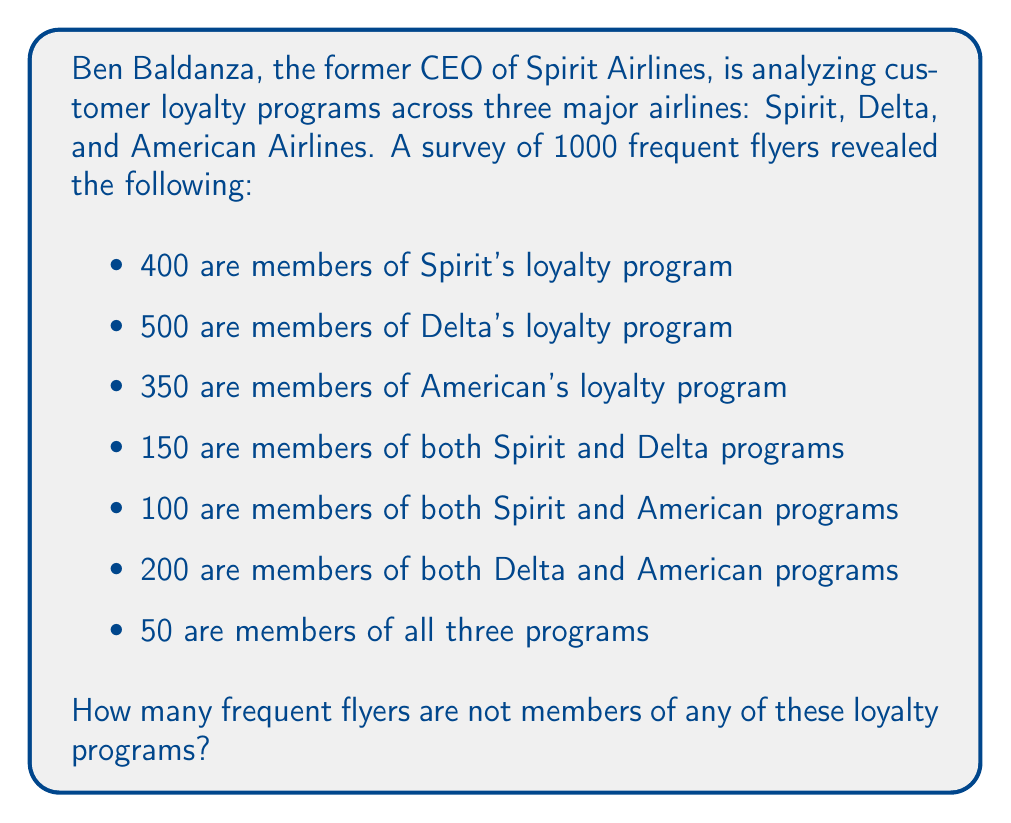Can you solve this math problem? To solve this problem, we'll use the principle of inclusion-exclusion and a Venn diagram to visualize the overlapping sets.

Let's define our sets:
S = Spirit members
D = Delta members
A = American Airlines members

We're given:
|S| = 400
|D| = 500
|A| = 350
|S ∩ D| = 150
|S ∩ A| = 100
|D ∩ A| = 200
|S ∩ D ∩ A| = 50

The total number of members in at least one program is:

$$ |S ∪ D ∪ A| = |S| + |D| + |A| - |S ∩ D| - |S ∩ A| - |D ∩ A| + |S ∩ D ∩ A| $$

Substituting the values:

$$ |S ∪ D ∪ A| = 400 + 500 + 350 - 150 - 100 - 200 + 50 = 850 $$

Therefore, out of 1000 frequent flyers, 850 are members of at least one loyalty program.

The number of frequent flyers not in any program is:

$$ 1000 - 850 = 150 $$

[asy]
unitsize(1cm);

pair A = (0,0), B = (2,0), C = (1,1.732);
draw(Circle(A,1));
draw(Circle(B,1));
draw(Circle(C,1));

label("S", A + (-0.7,-0.5));
label("D", B + (0.7,-0.5));
label("A", C + (0,0.8));

label("400", A + (-0.5,0.3));
label("500", B + (0.5,0.3));
label("350", C + (0,-0.7));

label("150", (A+B)/2);
label("100", (A+C)/2);
label("200", (B+C)/2);

label("50", (A+B+C)/3);

[/asy]
Answer: 150 frequent flyers are not members of any of these loyalty programs. 